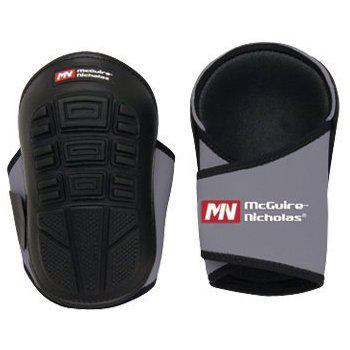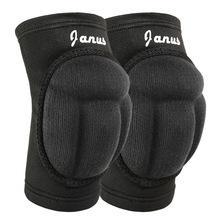The first image is the image on the left, the second image is the image on the right. Evaluate the accuracy of this statement regarding the images: "The right image shows a right-turned pair of pads, and the left image shows front and back views of a pair of pads.". Is it true? Answer yes or no. Yes. The first image is the image on the left, the second image is the image on the right. Considering the images on both sides, is "One of the knee pads has a white logo on the bottom" valid? Answer yes or no. No. 